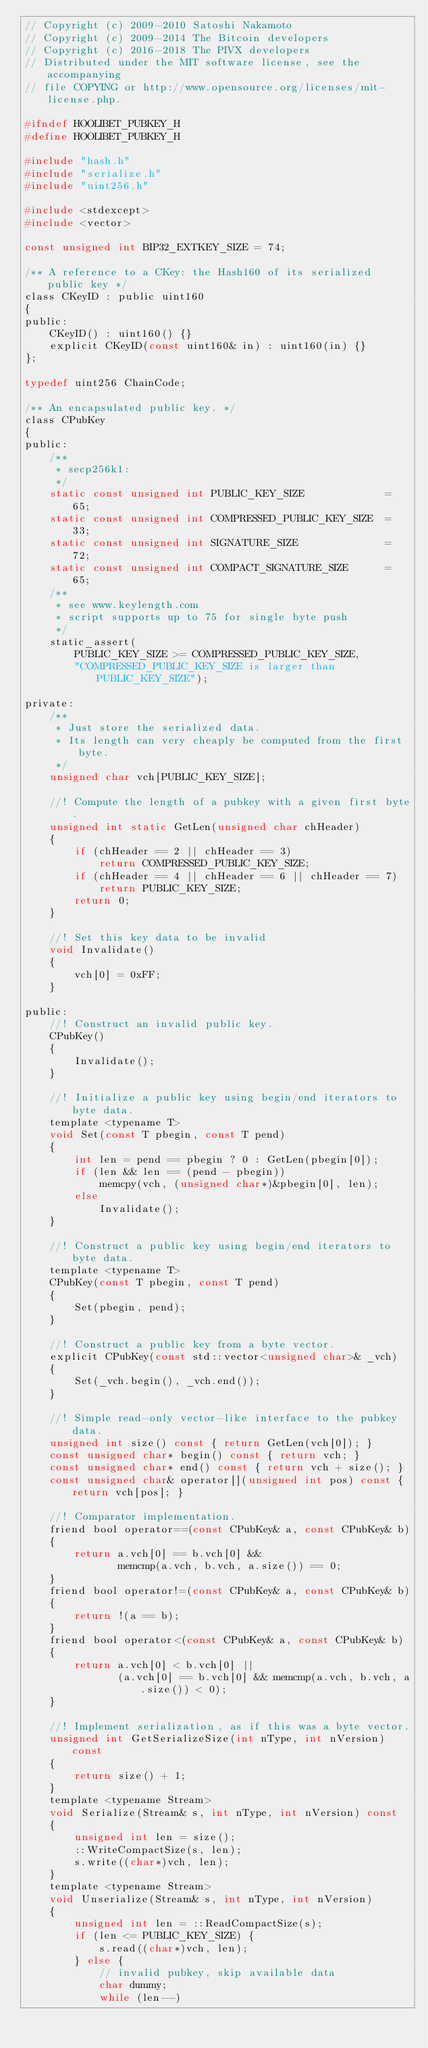<code> <loc_0><loc_0><loc_500><loc_500><_C_>// Copyright (c) 2009-2010 Satoshi Nakamoto
// Copyright (c) 2009-2014 The Bitcoin developers
// Copyright (c) 2016-2018 The PIVX developers
// Distributed under the MIT software license, see the accompanying
// file COPYING or http://www.opensource.org/licenses/mit-license.php.

#ifndef HOOLIBET_PUBKEY_H
#define HOOLIBET_PUBKEY_H

#include "hash.h"
#include "serialize.h"
#include "uint256.h"

#include <stdexcept>
#include <vector>

const unsigned int BIP32_EXTKEY_SIZE = 74;

/** A reference to a CKey: the Hash160 of its serialized public key */
class CKeyID : public uint160
{
public:
    CKeyID() : uint160() {}
    explicit CKeyID(const uint160& in) : uint160(in) {}
};

typedef uint256 ChainCode;

/** An encapsulated public key. */
class CPubKey
{
public:
    /**
     * secp256k1:
     */
    static const unsigned int PUBLIC_KEY_SIZE             = 65;
    static const unsigned int COMPRESSED_PUBLIC_KEY_SIZE  = 33;
    static const unsigned int SIGNATURE_SIZE              = 72;
    static const unsigned int COMPACT_SIGNATURE_SIZE      = 65;
    /**
     * see www.keylength.com
     * script supports up to 75 for single byte push
     */
    static_assert(
        PUBLIC_KEY_SIZE >= COMPRESSED_PUBLIC_KEY_SIZE,
        "COMPRESSED_PUBLIC_KEY_SIZE is larger than PUBLIC_KEY_SIZE");

private:
    /**
     * Just store the serialized data.
     * Its length can very cheaply be computed from the first byte.
     */
    unsigned char vch[PUBLIC_KEY_SIZE];

    //! Compute the length of a pubkey with a given first byte.
    unsigned int static GetLen(unsigned char chHeader)
    {
        if (chHeader == 2 || chHeader == 3)
            return COMPRESSED_PUBLIC_KEY_SIZE;
        if (chHeader == 4 || chHeader == 6 || chHeader == 7)
            return PUBLIC_KEY_SIZE;
        return 0;
    }

    //! Set this key data to be invalid
    void Invalidate()
    {
        vch[0] = 0xFF;
    }

public:
    //! Construct an invalid public key.
    CPubKey()
    {
        Invalidate();
    }

    //! Initialize a public key using begin/end iterators to byte data.
    template <typename T>
    void Set(const T pbegin, const T pend)
    {
        int len = pend == pbegin ? 0 : GetLen(pbegin[0]);
        if (len && len == (pend - pbegin))
            memcpy(vch, (unsigned char*)&pbegin[0], len);
        else
            Invalidate();
    }

    //! Construct a public key using begin/end iterators to byte data.
    template <typename T>
    CPubKey(const T pbegin, const T pend)
    {
        Set(pbegin, pend);
    }

    //! Construct a public key from a byte vector.
    explicit CPubKey(const std::vector<unsigned char>& _vch)
    {
        Set(_vch.begin(), _vch.end());
    }

    //! Simple read-only vector-like interface to the pubkey data.
    unsigned int size() const { return GetLen(vch[0]); }
    const unsigned char* begin() const { return vch; }
    const unsigned char* end() const { return vch + size(); }
    const unsigned char& operator[](unsigned int pos) const { return vch[pos]; }

    //! Comparator implementation.
    friend bool operator==(const CPubKey& a, const CPubKey& b)
    {
        return a.vch[0] == b.vch[0] &&
               memcmp(a.vch, b.vch, a.size()) == 0;
    }
    friend bool operator!=(const CPubKey& a, const CPubKey& b)
    {
        return !(a == b);
    }
    friend bool operator<(const CPubKey& a, const CPubKey& b)
    {
        return a.vch[0] < b.vch[0] ||
               (a.vch[0] == b.vch[0] && memcmp(a.vch, b.vch, a.size()) < 0);
    }

    //! Implement serialization, as if this was a byte vector.
    unsigned int GetSerializeSize(int nType, int nVersion) const
    {
        return size() + 1;
    }
    template <typename Stream>
    void Serialize(Stream& s, int nType, int nVersion) const
    {
        unsigned int len = size();
        ::WriteCompactSize(s, len);
        s.write((char*)vch, len);
    }
    template <typename Stream>
    void Unserialize(Stream& s, int nType, int nVersion)
    {
        unsigned int len = ::ReadCompactSize(s);
        if (len <= PUBLIC_KEY_SIZE) {
            s.read((char*)vch, len);
        } else {
            // invalid pubkey, skip available data
            char dummy;
            while (len--)</code> 